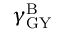Convert formula to latex. <formula><loc_0><loc_0><loc_500><loc_500>\gamma _ { G Y } ^ { B }</formula> 